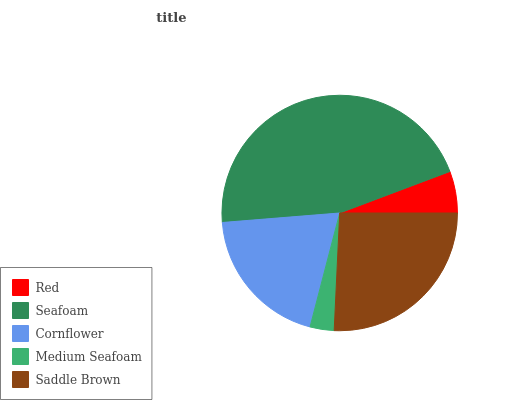Is Medium Seafoam the minimum?
Answer yes or no. Yes. Is Seafoam the maximum?
Answer yes or no. Yes. Is Cornflower the minimum?
Answer yes or no. No. Is Cornflower the maximum?
Answer yes or no. No. Is Seafoam greater than Cornflower?
Answer yes or no. Yes. Is Cornflower less than Seafoam?
Answer yes or no. Yes. Is Cornflower greater than Seafoam?
Answer yes or no. No. Is Seafoam less than Cornflower?
Answer yes or no. No. Is Cornflower the high median?
Answer yes or no. Yes. Is Cornflower the low median?
Answer yes or no. Yes. Is Medium Seafoam the high median?
Answer yes or no. No. Is Seafoam the low median?
Answer yes or no. No. 